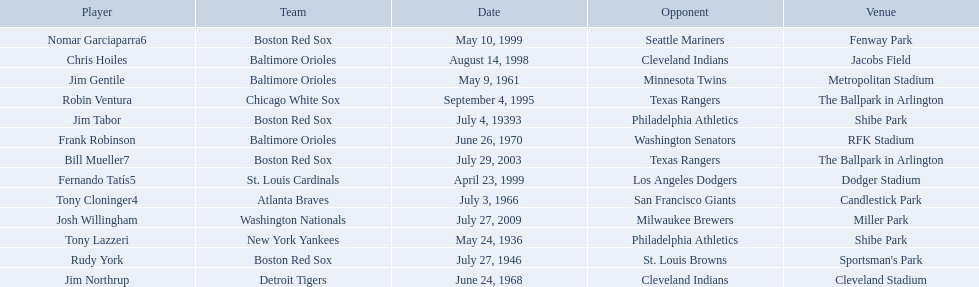Who were all of the players? Tony Lazzeri, Jim Tabor, Rudy York, Jim Gentile, Tony Cloninger4, Jim Northrup, Frank Robinson, Robin Ventura, Chris Hoiles, Fernando Tatís5, Nomar Garciaparra6, Bill Mueller7, Josh Willingham. What year was there a player for the yankees? May 24, 1936. What was the name of that 1936 yankees player? Tony Lazzeri. 